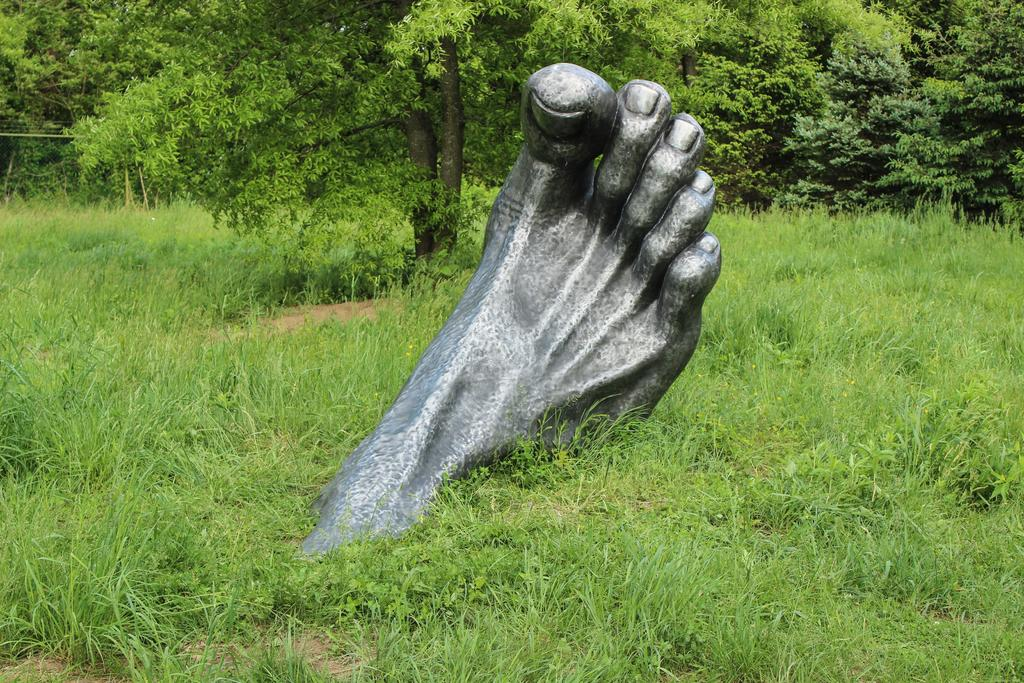What is the main subject of the image? The main subject of the image is a leg. Where is the leg located in the image? The leg is on the grass. What can be seen in the background of the image? There are trees in the background of the image. What type of badge is attached to the leg in the image? There is no badge present in the image; it only depicts a leg on the grass with trees in the background. 